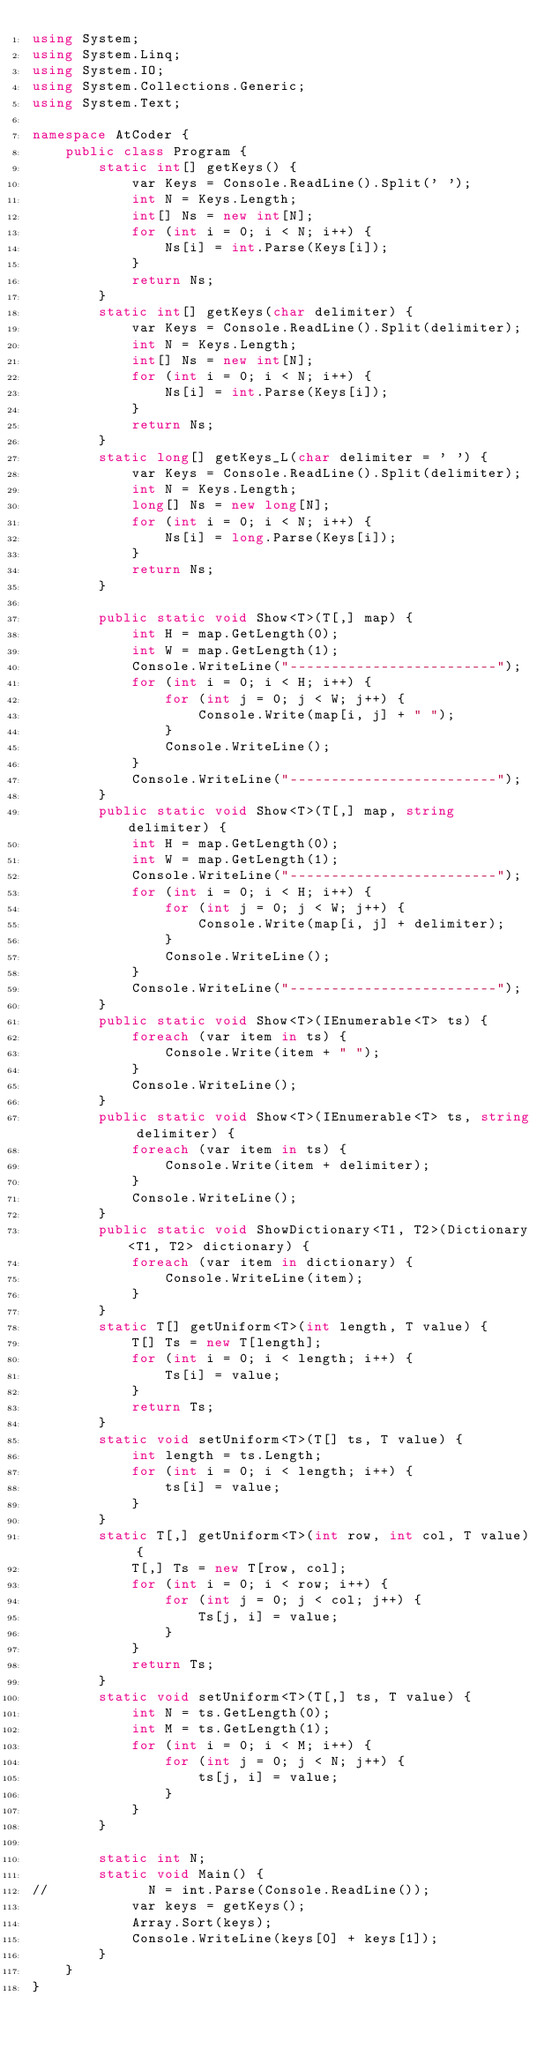Convert code to text. <code><loc_0><loc_0><loc_500><loc_500><_C#_>using System;
using System.Linq;
using System.IO;
using System.Collections.Generic;
using System.Text;

namespace AtCoder {
    public class Program {
        static int[] getKeys() {
            var Keys = Console.ReadLine().Split(' ');
            int N = Keys.Length;
            int[] Ns = new int[N];
            for (int i = 0; i < N; i++) {
                Ns[i] = int.Parse(Keys[i]);
            }
            return Ns;
        }
        static int[] getKeys(char delimiter) {
            var Keys = Console.ReadLine().Split(delimiter);
            int N = Keys.Length;
            int[] Ns = new int[N];
            for (int i = 0; i < N; i++) {
                Ns[i] = int.Parse(Keys[i]);
            }
            return Ns;
        }
        static long[] getKeys_L(char delimiter = ' ') {
            var Keys = Console.ReadLine().Split(delimiter);
            int N = Keys.Length;
            long[] Ns = new long[N];
            for (int i = 0; i < N; i++) {
                Ns[i] = long.Parse(Keys[i]);
            }
            return Ns;
        }

        public static void Show<T>(T[,] map) {
            int H = map.GetLength(0);
            int W = map.GetLength(1);
            Console.WriteLine("-------------------------");
            for (int i = 0; i < H; i++) {
                for (int j = 0; j < W; j++) {
                    Console.Write(map[i, j] + " ");
                }
                Console.WriteLine();
            }
            Console.WriteLine("-------------------------");
        }
        public static void Show<T>(T[,] map, string delimiter) {
            int H = map.GetLength(0);
            int W = map.GetLength(1);
            Console.WriteLine("-------------------------");
            for (int i = 0; i < H; i++) {
                for (int j = 0; j < W; j++) {
                    Console.Write(map[i, j] + delimiter);
                }
                Console.WriteLine();
            }
            Console.WriteLine("-------------------------");
        }
        public static void Show<T>(IEnumerable<T> ts) {
            foreach (var item in ts) {
                Console.Write(item + " ");
            }
            Console.WriteLine();
        }
        public static void Show<T>(IEnumerable<T> ts, string delimiter) {
            foreach (var item in ts) {
                Console.Write(item + delimiter);
            }
            Console.WriteLine();
        }
        public static void ShowDictionary<T1, T2>(Dictionary<T1, T2> dictionary) {
            foreach (var item in dictionary) {
                Console.WriteLine(item);
            }
        }
        static T[] getUniform<T>(int length, T value) {
            T[] Ts = new T[length];
            for (int i = 0; i < length; i++) {
                Ts[i] = value;
            }
            return Ts;
        }
        static void setUniform<T>(T[] ts, T value) {
            int length = ts.Length;
            for (int i = 0; i < length; i++) {
                ts[i] = value;
            }
        }
        static T[,] getUniform<T>(int row, int col, T value) {
            T[,] Ts = new T[row, col];
            for (int i = 0; i < row; i++) {
                for (int j = 0; j < col; j++) {
                    Ts[j, i] = value;
                }
            }
            return Ts;
        }
        static void setUniform<T>(T[,] ts, T value) {
            int N = ts.GetLength(0);
            int M = ts.GetLength(1);
            for (int i = 0; i < M; i++) {
                for (int j = 0; j < N; j++) {
                    ts[j, i] = value;
                }
            }
        }

        static int N;
        static void Main() {
//            N = int.Parse(Console.ReadLine());
            var keys = getKeys();
            Array.Sort(keys);
            Console.WriteLine(keys[0] + keys[1]);
        }
    }
}</code> 